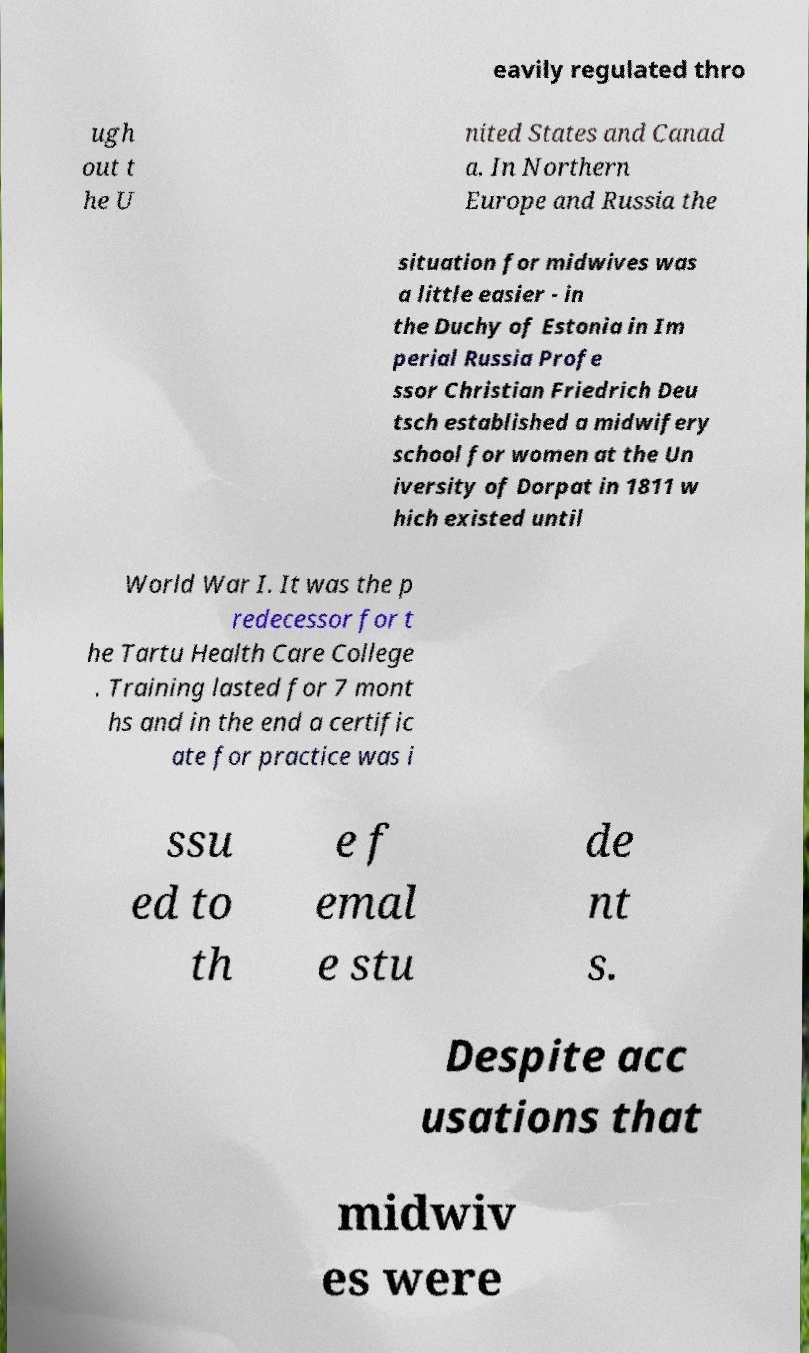Could you extract and type out the text from this image? eavily regulated thro ugh out t he U nited States and Canad a. In Northern Europe and Russia the situation for midwives was a little easier - in the Duchy of Estonia in Im perial Russia Profe ssor Christian Friedrich Deu tsch established a midwifery school for women at the Un iversity of Dorpat in 1811 w hich existed until World War I. It was the p redecessor for t he Tartu Health Care College . Training lasted for 7 mont hs and in the end a certific ate for practice was i ssu ed to th e f emal e stu de nt s. Despite acc usations that midwiv es were 